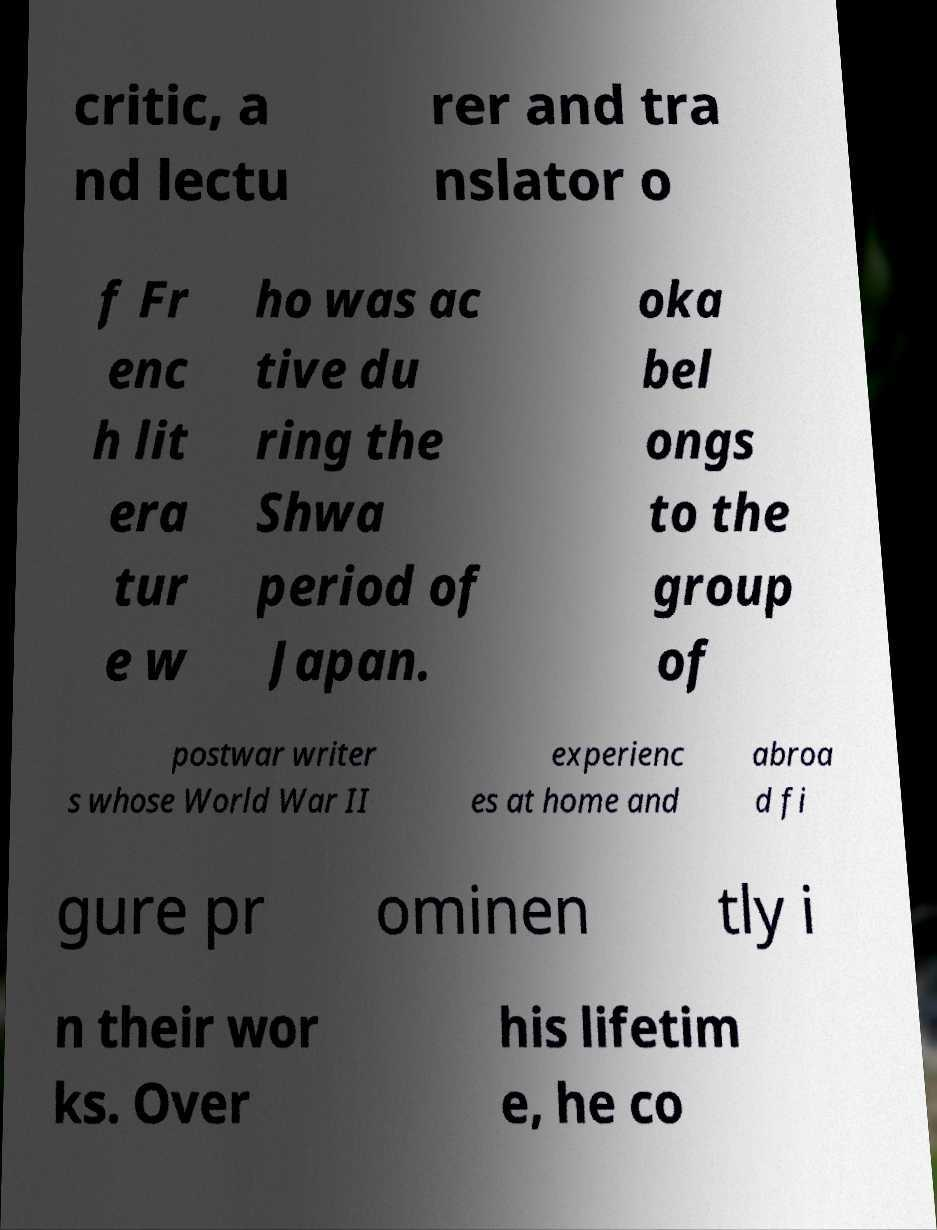Could you assist in decoding the text presented in this image and type it out clearly? critic, a nd lectu rer and tra nslator o f Fr enc h lit era tur e w ho was ac tive du ring the Shwa period of Japan. oka bel ongs to the group of postwar writer s whose World War II experienc es at home and abroa d fi gure pr ominen tly i n their wor ks. Over his lifetim e, he co 